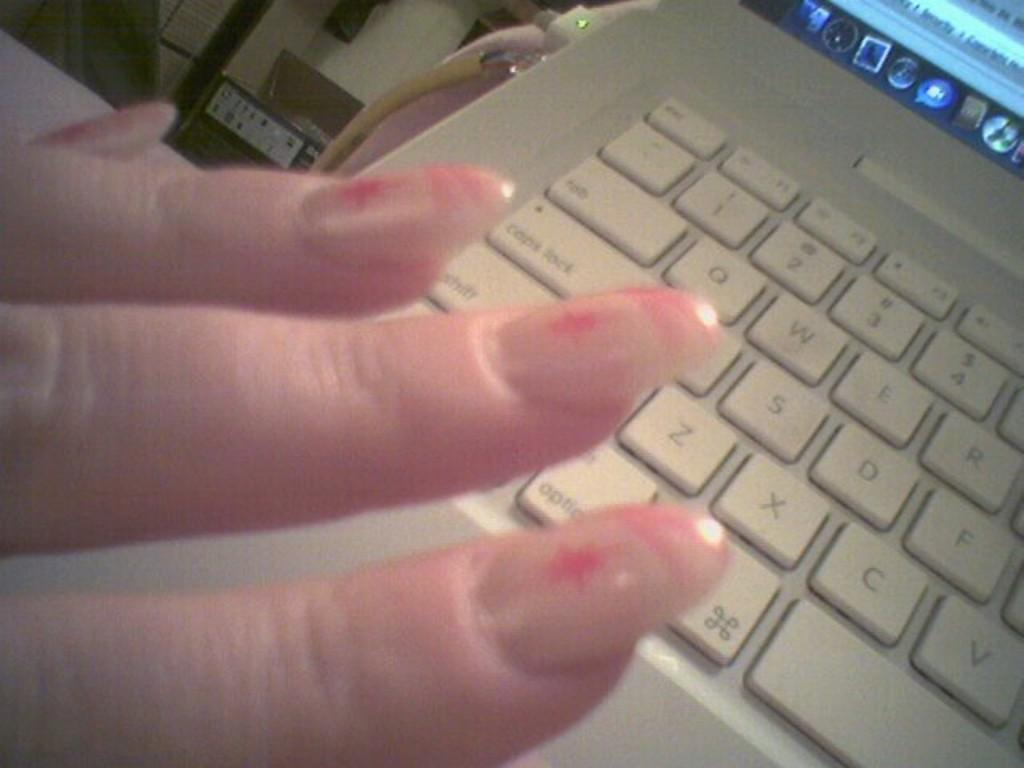Provide a one-sentence caption for the provided image. The C, V and F keys, among others, are visible on a computer keyboard. 